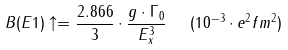Convert formula to latex. <formula><loc_0><loc_0><loc_500><loc_500>B ( E 1 ) \uparrow = \frac { 2 . 8 6 6 } { 3 } \cdot \frac { g \cdot \Gamma _ { 0 } } { E ^ { 3 } _ { x } } \ \ ( 1 0 ^ { - 3 } \cdot e ^ { 2 } f m ^ { 2 } )</formula> 